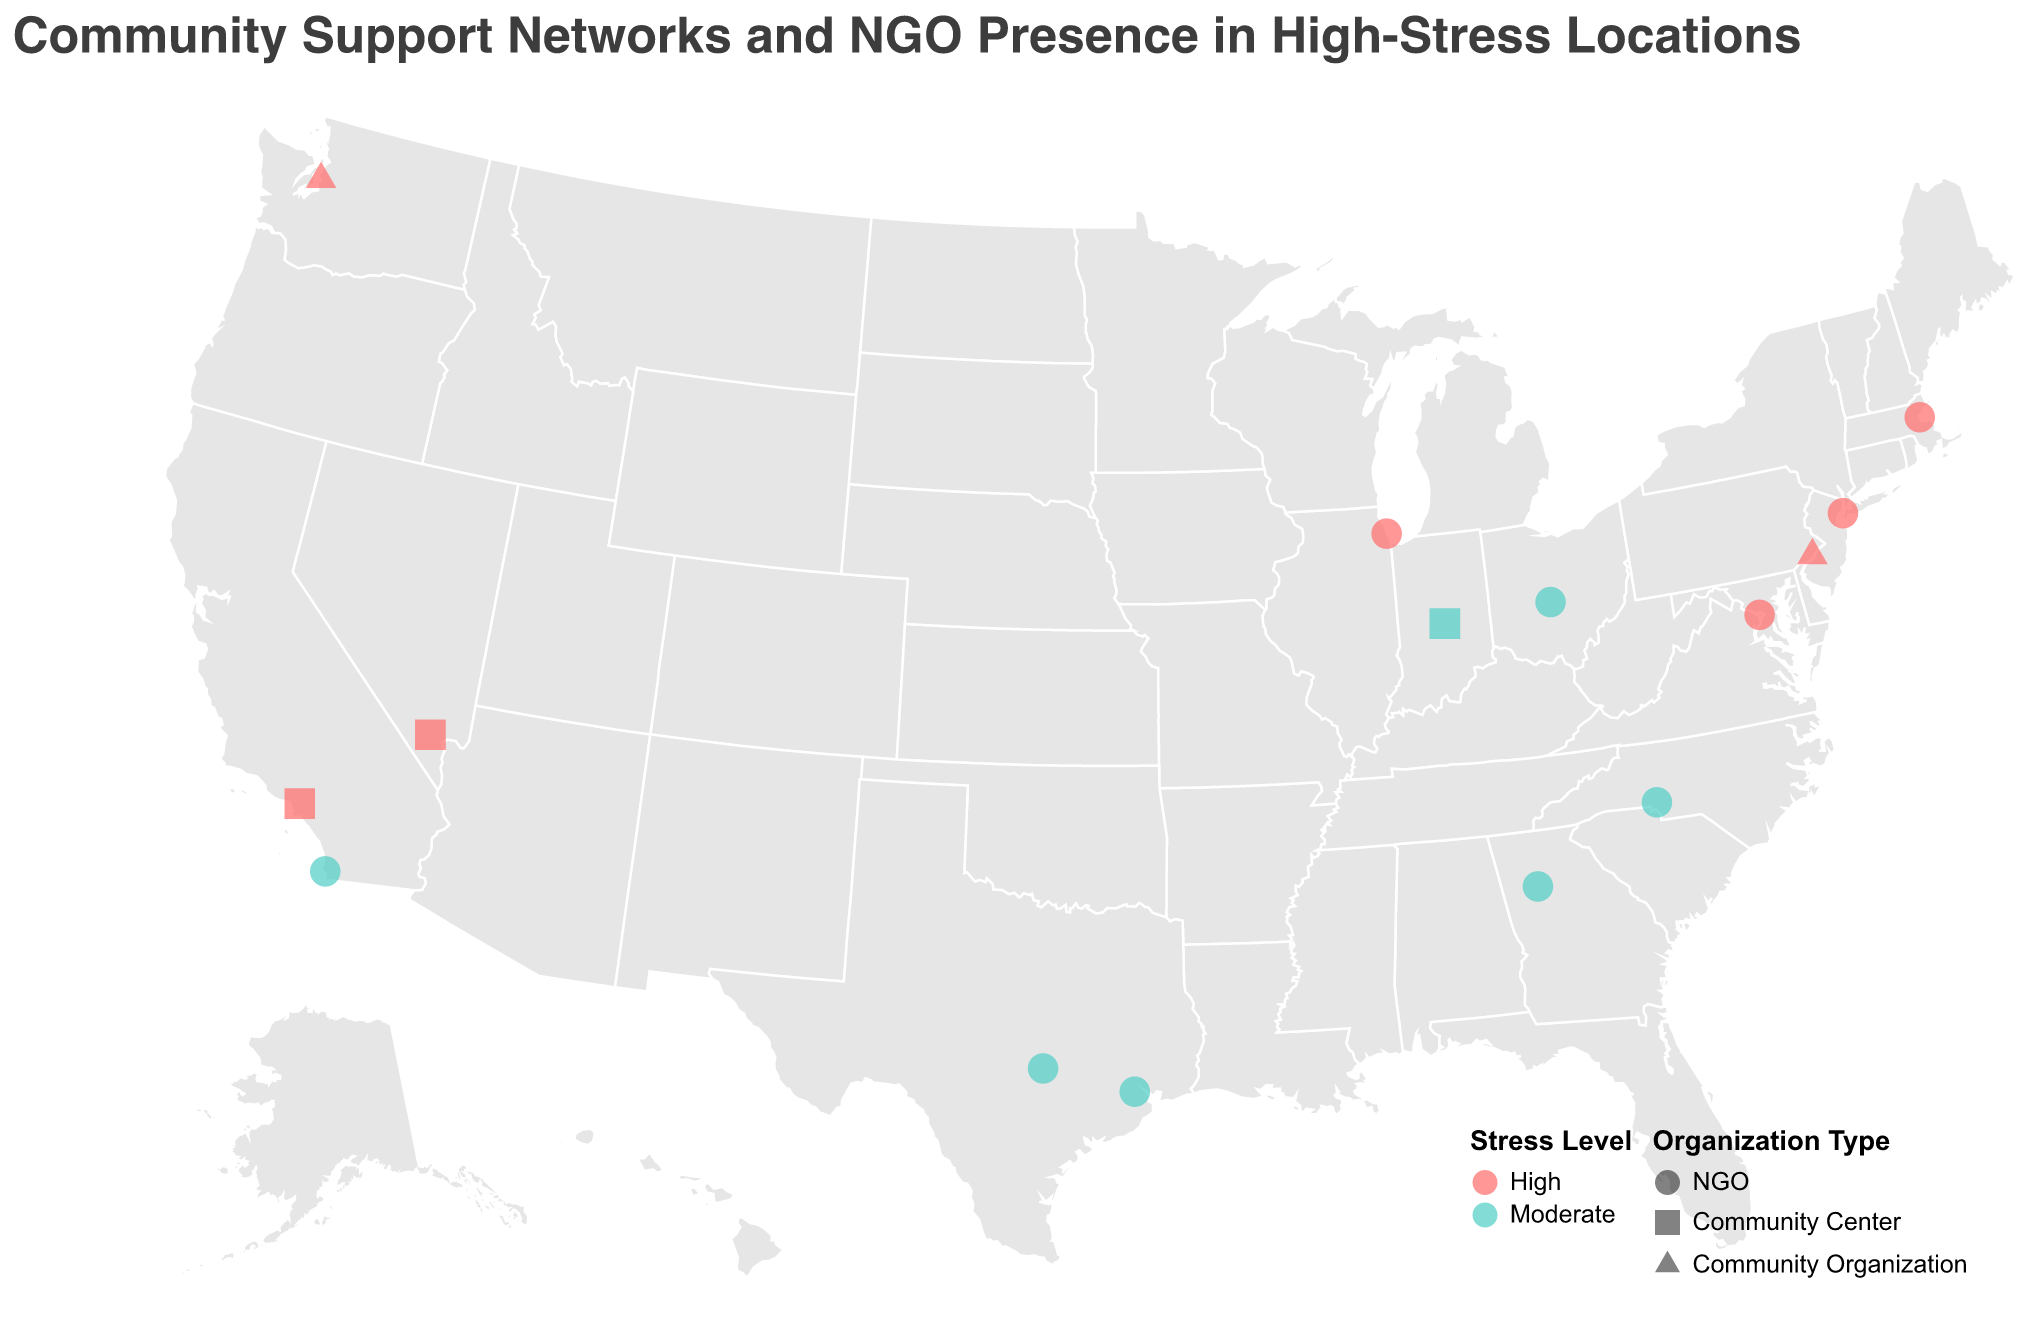What is the title of the figure? The title of the figure is displayed at the top and reads: "Community Support Networks and NGO Presence in High-Stress Locations".
Answer: Community Support Networks and NGO Presence in High-Stress Locations How many locations are marked as having high stress levels on the map? The locations marked as having high stress levels are represented by the color red. By counting these red-colored points, we identify the high-stress locations: New York City, Los Angeles, Chicago, Philadelphia, Boston, Seattle, Washington D.C., and Las Vegas.
Answer: 8 Which locations have NGOs that offer mobile app support as a service? We need to check the tooltip information for each location and identify those that mention "Mobile App Support" as part of their services. These locations are Chicago, Charlotte, Boston, and Columbus.
Answer: Chicago, Charlotte, Boston, Columbus Compare the number of NGOs to community centers in the figure. Which type is more common? NGOs are represented by circles while community centers are represented by squares on the map. By counting each shape, we see more circles (NGOs) than squares (community centers).
Answer: NGOs Which city has a community organization providing forest bathing and digital mental health tools? We need to find the city that lists "Forest Bathing" and "Digital Mental Health Tools" under Services in the tooltip for community organizations. This city is Seattle.
Answer: Seattle What's the most common service provided by these organizations? By examining the tooltip information for each data point and noting the services offered, we see that many locations provide some form of mental health app or online support tools.
Answer: Mental health app/Online support Are there more high-stress locations or moderate-stress locations on the map? High-stress locations are marked in red, and moderate-stress locations are marked in teal. By counting each type, we see eight high-stress and six moderate-stress locations.
Answer: High-stress locations Which high-stress location has multiple organizations listed, and what services do they offer? We need to examine the map for high-stress locations and check if any have more than one organization. Each tooltip should be reviewed for multiple entries. However, based on the provided data, none of the high-stress locations have multiple organizations listed in this dataset.
Answer: None In which city can you find a community garden as part of stress management services? Checking the tooltip information under "Services" for the mentioned term "Community Garden," we find Houston and Charlotte listed offering this service.
Answer: Houston, Charlotte Which high-stress city provides virtual reality relaxation as one of its services? By looking for high-stress locations and reviewing their services in the tooltip, we see that Indianapolis, which has moderate stress, provides virtual reality relaxation, but none of the high-stress locations offer this service.
Answer: None 